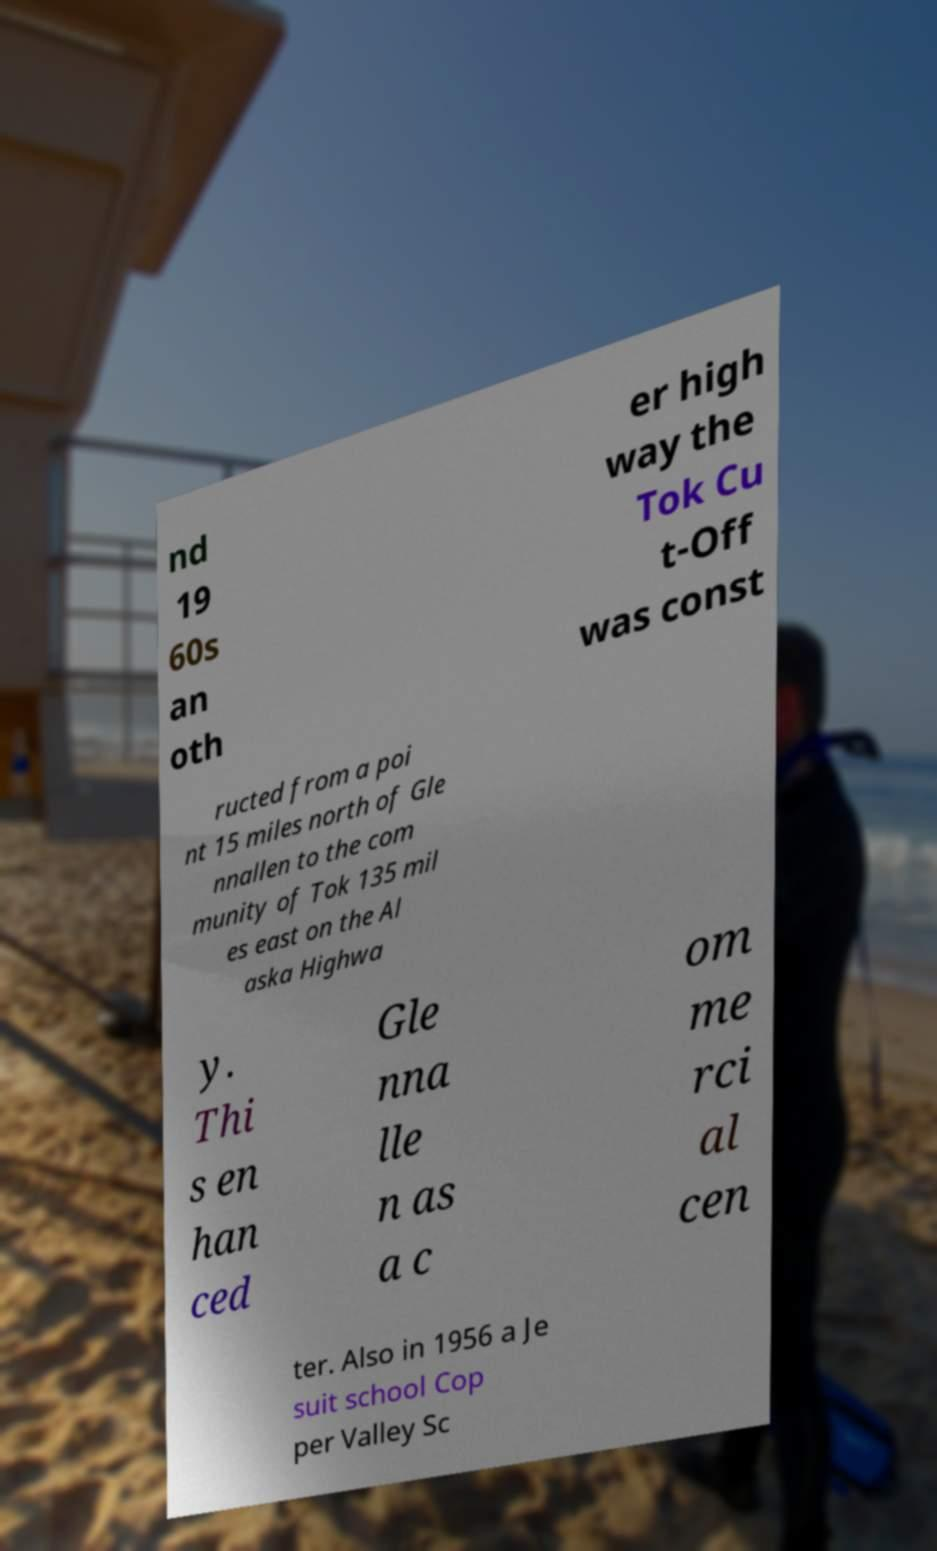For documentation purposes, I need the text within this image transcribed. Could you provide that? nd 19 60s an oth er high way the Tok Cu t-Off was const ructed from a poi nt 15 miles north of Gle nnallen to the com munity of Tok 135 mil es east on the Al aska Highwa y. Thi s en han ced Gle nna lle n as a c om me rci al cen ter. Also in 1956 a Je suit school Cop per Valley Sc 